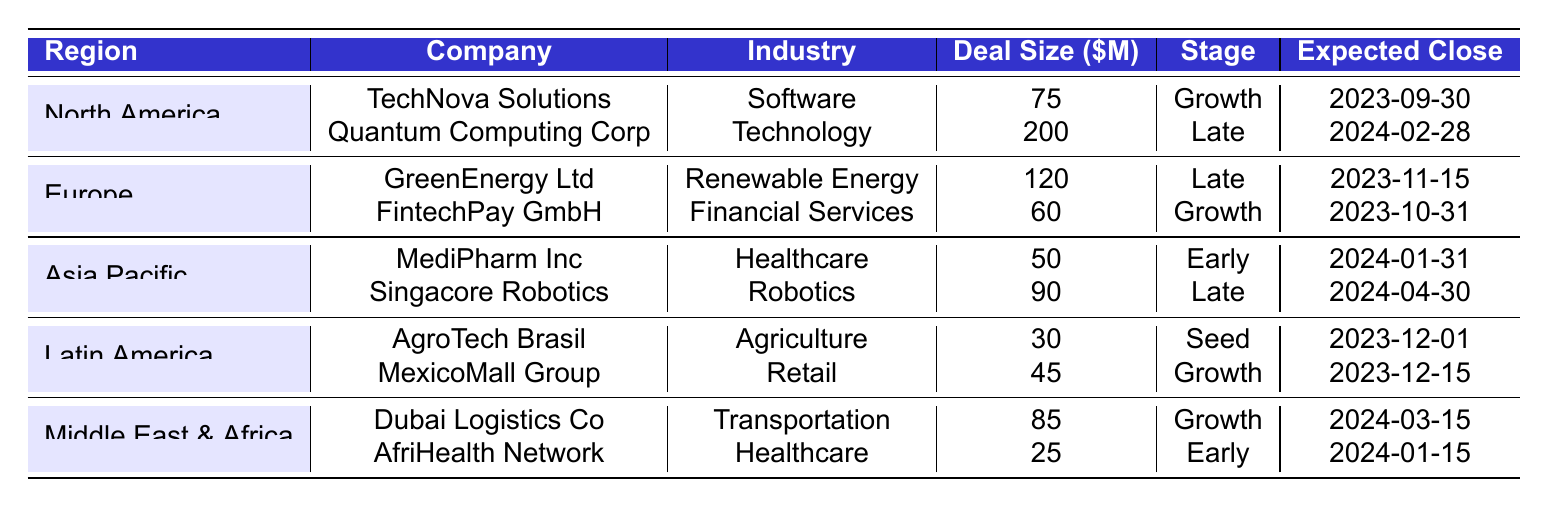What is the total deal value for investment opportunities in North America? The deal values for North America are 75 million for TechNova Solutions and 200 million for Quantum Computing Corp. Adding these together gives us 75 + 200 = 275 million.
Answer: 275 million Which region has the highest average deal size? To find the average deal size for each region, sum the deal sizes in each region and divide by the number of deals. North America: (75 + 200) / 2 = 137.5 million, Europe: (120 + 60) / 2 = 90 million, Asia Pacific: (50 + 90) / 2 = 70 million, Latin America: (30 + 45) / 2 = 37.5 million, Middle East & Africa: (85 + 25) / 2 = 55 million. The highest average is in North America at 137.5 million.
Answer: North America How many deals in total are at the Growth stage? There are four deals in the Growth stage listed in the table: TechNova Solutions, FintechPay GmbH, MexicoMall Group, and Dubai Logistics Co.
Answer: 4 Is there any company involved in the Agriculture industry in Europe? There is no company listed in the Agriculture industry in the Europe section of the table; AgroTech Brasil, which operates in Agriculture, is listed under Latin America.
Answer: No What is the expected close date of the earliest deal in Asia Pacific? The expected close dates for the deals in Asia Pacific are January 31, 2024, for MediPharm Inc and April 30, 2024, for Singacore Robotics. The earliest date is January 31, 2024.
Answer: January 31, 2024 Which industry has the most representation in the deal flow pipeline? The industry representation shows Healthcare with two companies (MediPharm Inc and AfriHealth Network) and all others with one company each, making Healthcare the most represented industry in the pipeline.
Answer: Healthcare What is the total deal size for companies in the Middle East & Africa region? The deal sizes for Middle East & Africa are 85 million for Dubai Logistics Co and 25 million for AfriHealth Network. Summing these gives us 85 + 25 = 110 million.
Answer: 110 million Is there a company in the Renewable Energy sector that has a deal size less than 100 million? Yes, GreenEnergy Ltd in the Renewable Energy sector has a deal size of 120 million, which is more than 100 million. So there is no company in the sector with a deal size less than 100 million.
Answer: No What is the total number of deals in the Seed stage? There is one company listed in the Seed stage, which is AgroTech Brasil. Therefore, the total number of deals in the Seed stage is 1.
Answer: 1 How many companies from Latin America are in the Growth stage? Latin America has one company listed in the Growth stage, which is MexicoMall Group. Therefore, there is 1 company from Latin America in that stage.
Answer: 1 Which region has the least number of deals listed in the table? Latin America has only two companies listed in the pipeline, which is fewer than the other regions. North America, Europe, Asia Pacific, and Middle East & Africa each have at least four companies.
Answer: Latin America 